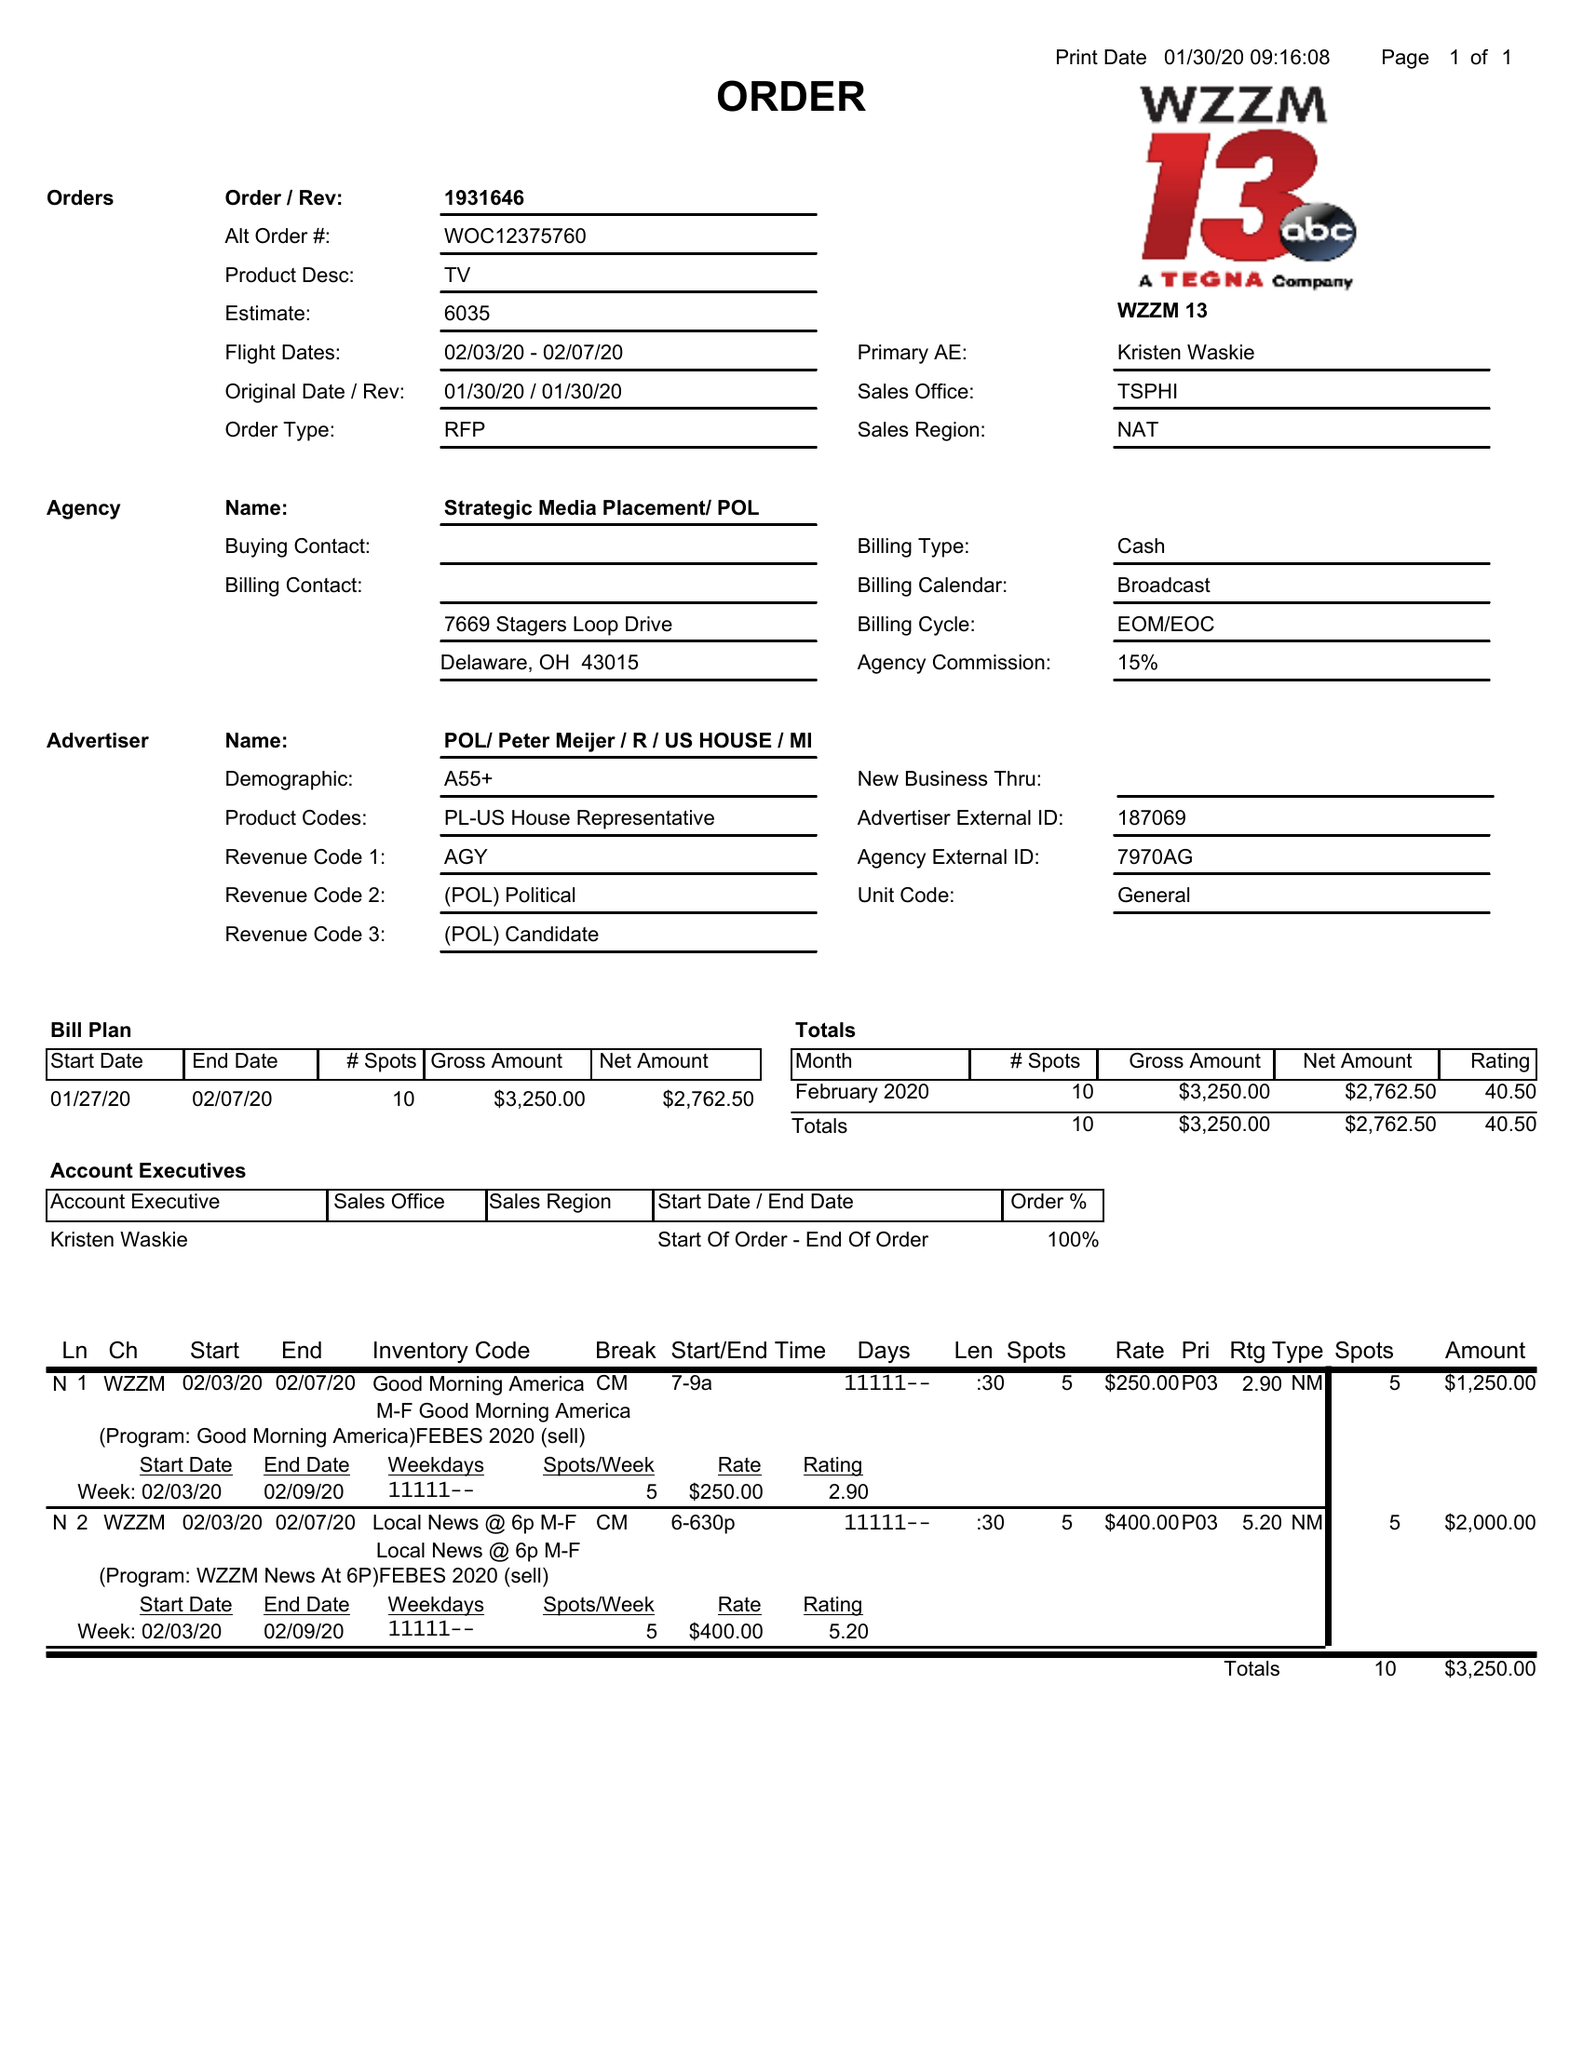What is the value for the flight_to?
Answer the question using a single word or phrase. 02/03/20 